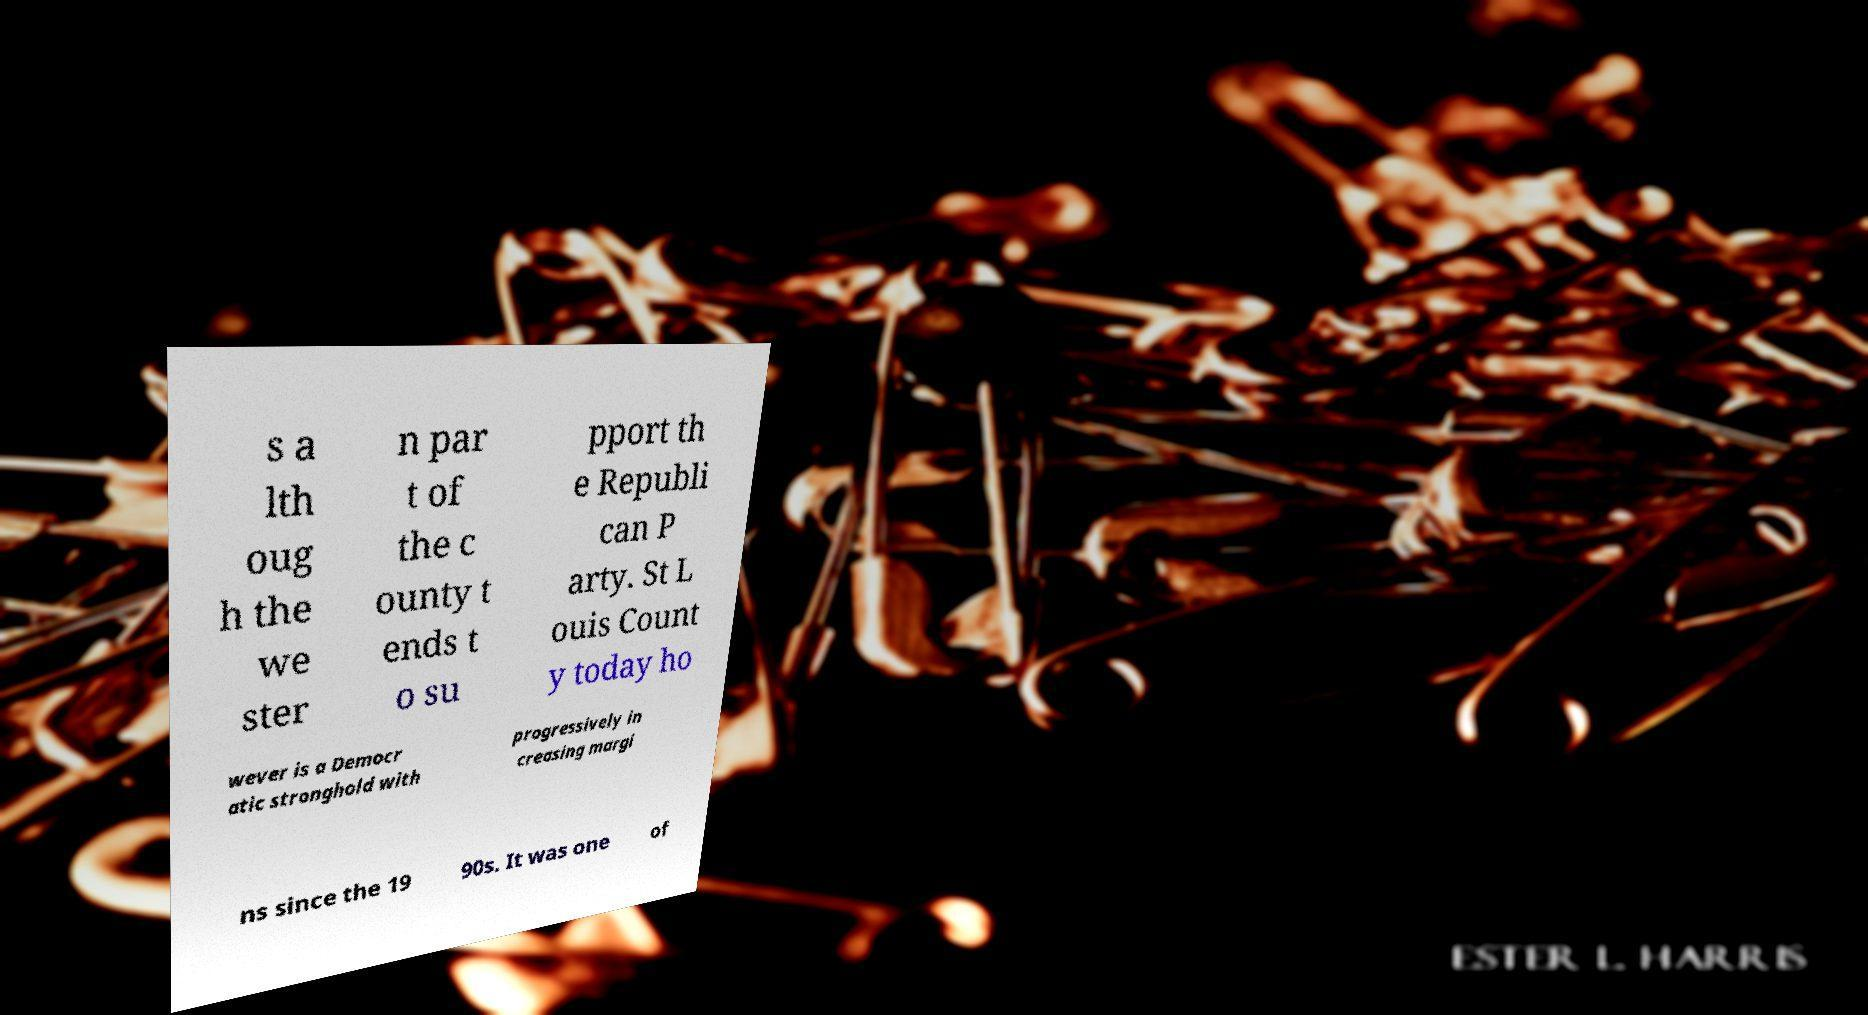Could you assist in decoding the text presented in this image and type it out clearly? s a lth oug h the we ster n par t of the c ounty t ends t o su pport th e Republi can P arty. St L ouis Count y today ho wever is a Democr atic stronghold with progressively in creasing margi ns since the 19 90s. It was one of 